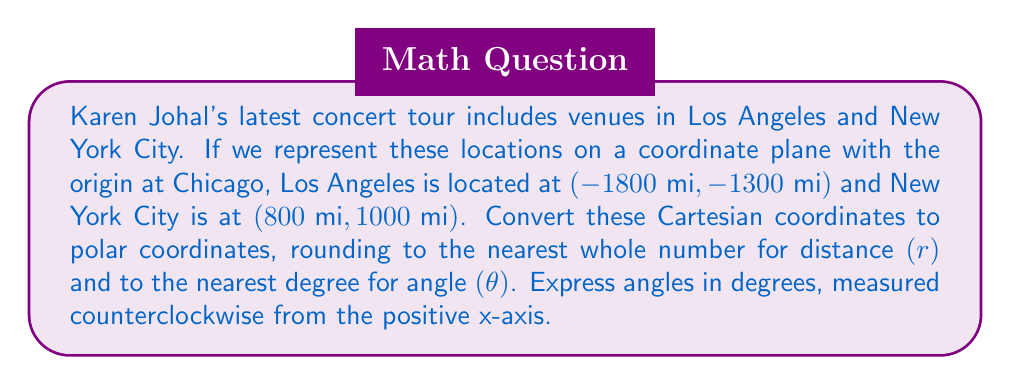Solve this math problem. To convert from Cartesian coordinates (x, y) to polar coordinates (r, θ), we use the following formulas:

1. $r = \sqrt{x^2 + y^2}$
2. $\theta = \tan^{-1}(\frac{y}{x})$

For Los Angeles (-1800, -1300):

1. Calculate r:
   $$r = \sqrt{(-1800)^2 + (-1300)^2} = \sqrt{3,240,000 + 1,690,000} = \sqrt{4,930,000} \approx 2220$$

2. Calculate θ:
   $$\theta = \tan^{-1}(\frac{-1300}{-1800}) = \tan^{-1}(0.7222) \approx 35.84°$$
   
   However, since both x and y are negative, we need to add 180° to this result:
   $$35.84° + 180° = 215.84° \approx 216°$$

For New York City (800, 1000):

1. Calculate r:
   $$r = \sqrt{800^2 + 1000^2} = \sqrt{640,000 + 1,000,000} = \sqrt{1,640,000} \approx 1281$$

2. Calculate θ:
   $$\theta = \tan^{-1}(\frac{1000}{800}) = \tan^{-1}(1.25) \approx 51.34° \approx 51°$$

Rounding to the nearest whole number for distance and nearest degree for angle, we get:

Los Angeles: (2220, 216°)
New York City: (1281, 51°)
Answer: Los Angeles: (2220, 216°)
New York City: (1281, 51°) 